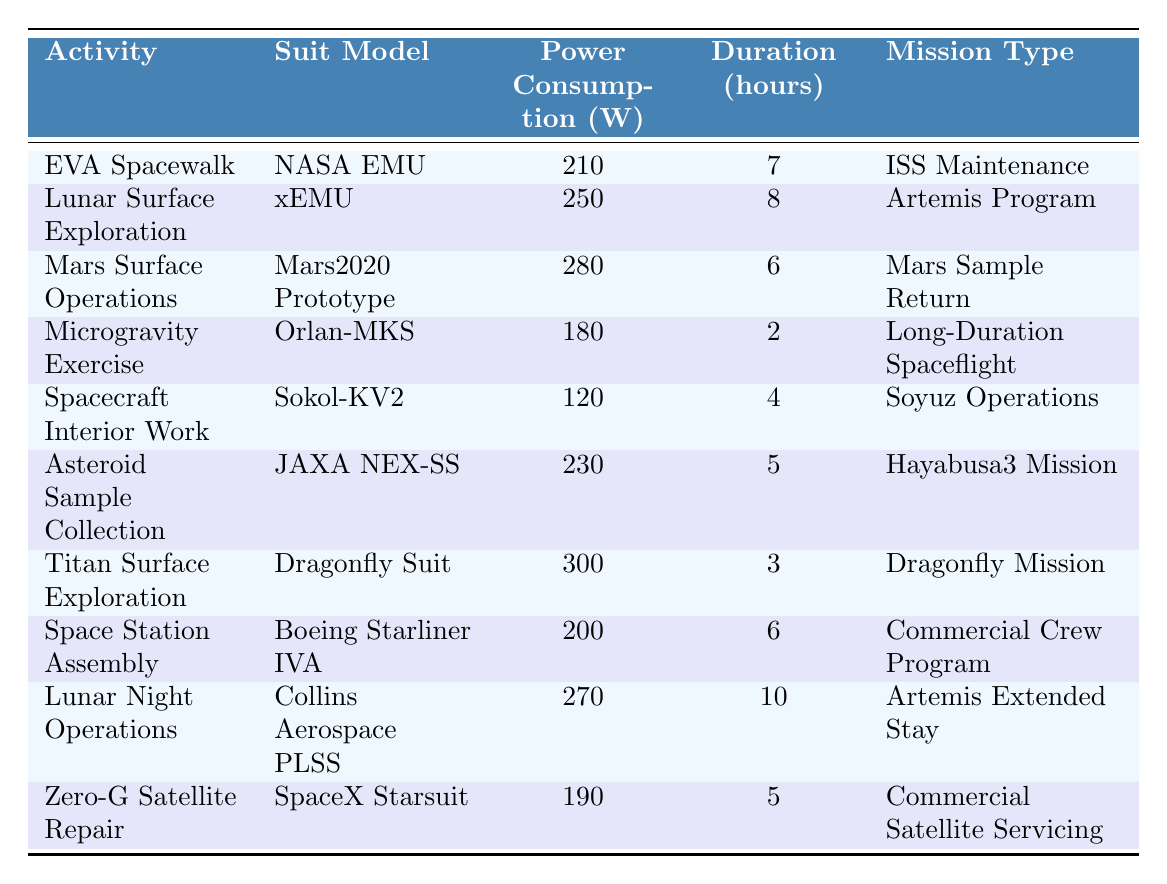What is the power consumption of the NASA EMU during an EVA Spacewalk? According to the table, the power consumption specified for the NASA EMU during an EVA Spacewalk is 210 Watts.
Answer: 210 Watts Which suit has the highest power consumption? The table shows the Dragonfly Suit for Titan Surface Exploration with a power consumption of 300 Watts, which is higher than any other suit listed.
Answer: Dragonfly Suit What is the total power consumption of suits used in Artemis missions? The suits listed for Artemis missions are xEMU (250 Watts) and Collins Aerospace PLSS (270 Watts). Adding these gives (250 + 270) = 520 Watts.
Answer: 520 Watts How long is the average duration of activities in the table? To find the average duration, sum the durations: (7 + 8 + 6 + 2 + 4 + 5 + 3 + 6 + 10 + 5) = 56 hours. There are 10 activities, so the average is 56/10 = 5.6 hours.
Answer: 5.6 hours Is the power consumption of Microgravity Exercise less than 200 Watts? The table indicates that Microgravity Exercise consumes 180 Watts, which is indeed less than 200 Watts.
Answer: Yes Which suit is used for Mars Surface Operations and what is its power consumption? The Mars2020 Prototype is the suit listed for Mars Surface Operations, with a power consumption of 280 Watts.
Answer: Mars2020 Prototype, 280 Watts What is the difference in power consumption between Lunar Night Operations and Spacecraft Interior Work? The power consumption for Lunar Night Operations is 270 Watts and for Spacecraft Interior Work is 120 Watts. The difference is (270 - 120) = 150 Watts.
Answer: 150 Watts How many activities have a power consumption greater than 250 Watts? From the table, the activities with power consumption greater than 250 Watts are Lunar Surface Exploration (250), Mars Surface Operations (280), Titan Surface Exploration (300), and Lunar Night Operations (270). This gives a total of 4 activities.
Answer: 4 activities What is the duration of the activity with the least power consumption? The activity with the least power consumption is Spacecraft Interior Work, which has a duration of 4 hours.
Answer: 4 hours Are there any activities with a power consumption of exactly 200 Watts? Yes, the Space Station Assembly activity has a power consumption of exactly 200 Watts as indicated in the table.
Answer: Yes 